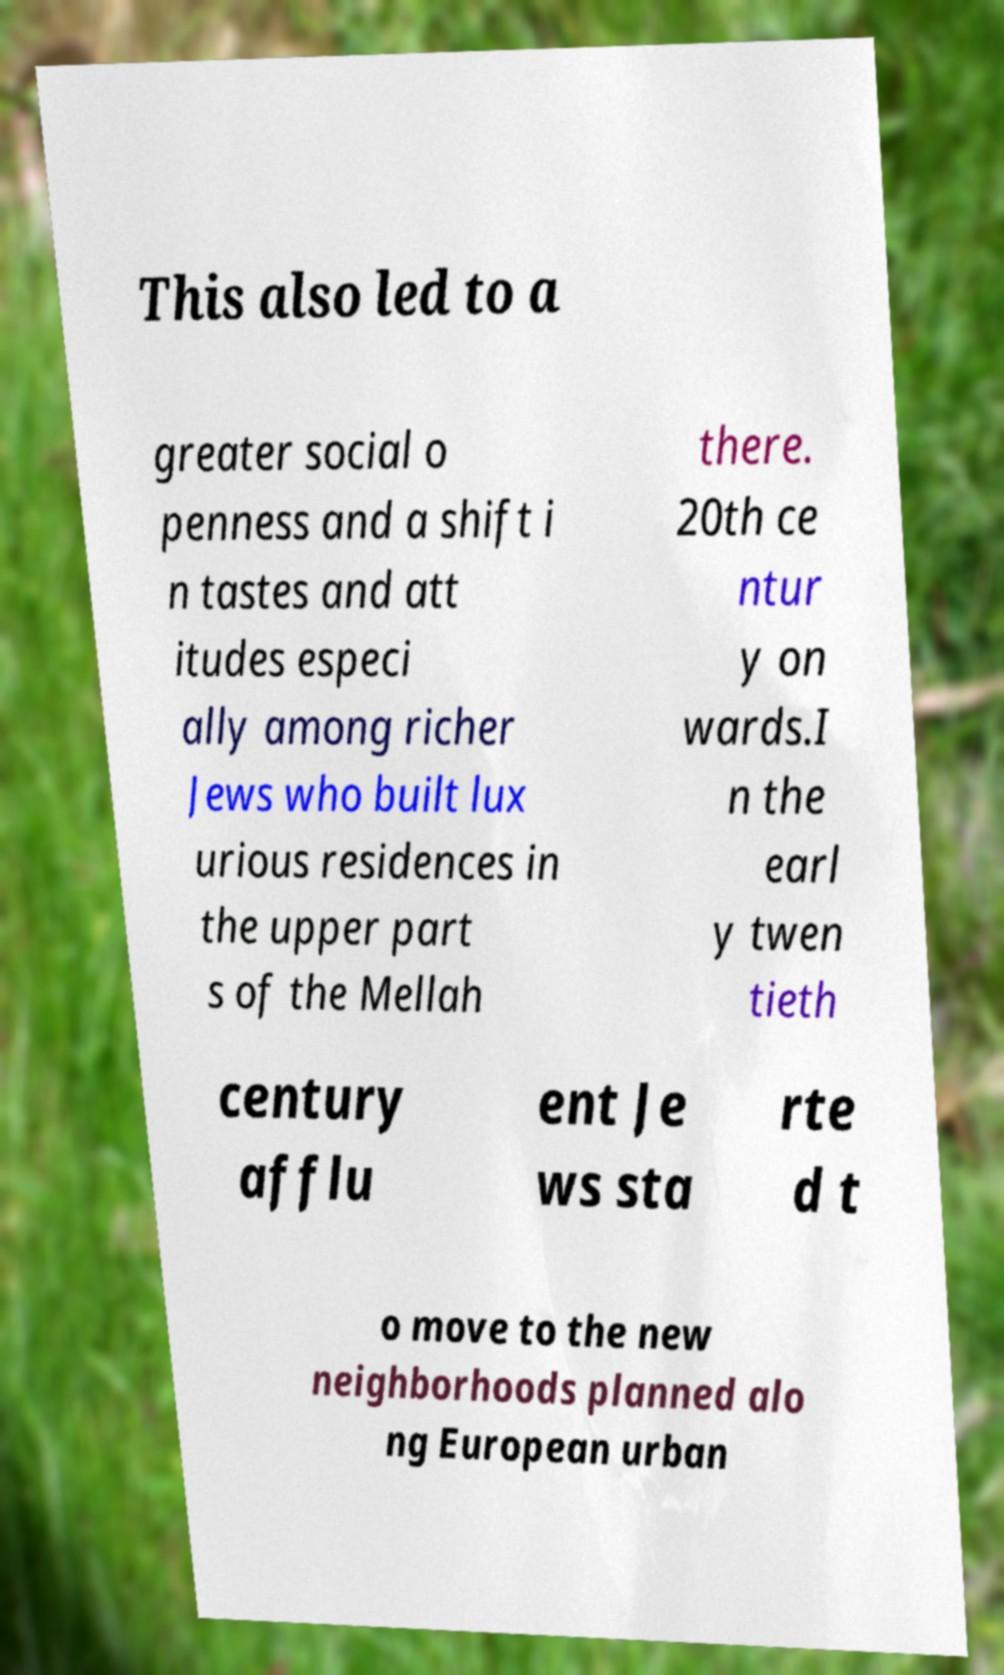Please read and relay the text visible in this image. What does it say? This also led to a greater social o penness and a shift i n tastes and att itudes especi ally among richer Jews who built lux urious residences in the upper part s of the Mellah there. 20th ce ntur y on wards.I n the earl y twen tieth century afflu ent Je ws sta rte d t o move to the new neighborhoods planned alo ng European urban 